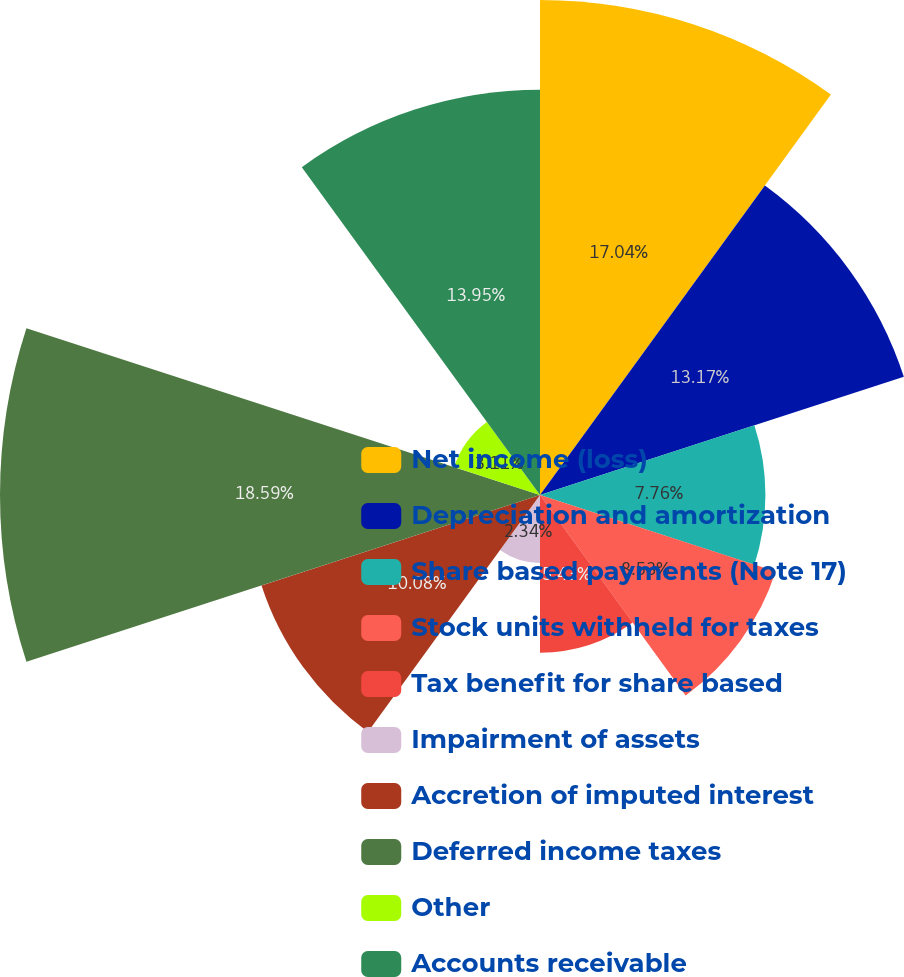Convert chart. <chart><loc_0><loc_0><loc_500><loc_500><pie_chart><fcel>Net income (loss)<fcel>Depreciation and amortization<fcel>Share based payments (Note 17)<fcel>Stock units withheld for taxes<fcel>Tax benefit for share based<fcel>Impairment of assets<fcel>Accretion of imputed interest<fcel>Deferred income taxes<fcel>Other<fcel>Accounts receivable<nl><fcel>17.04%<fcel>13.17%<fcel>7.76%<fcel>8.53%<fcel>5.43%<fcel>2.34%<fcel>10.08%<fcel>18.59%<fcel>3.11%<fcel>13.95%<nl></chart> 